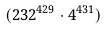Convert formula to latex. <formula><loc_0><loc_0><loc_500><loc_500>( 2 3 2 ^ { 4 2 9 } \cdot 4 ^ { 4 3 1 } )</formula> 